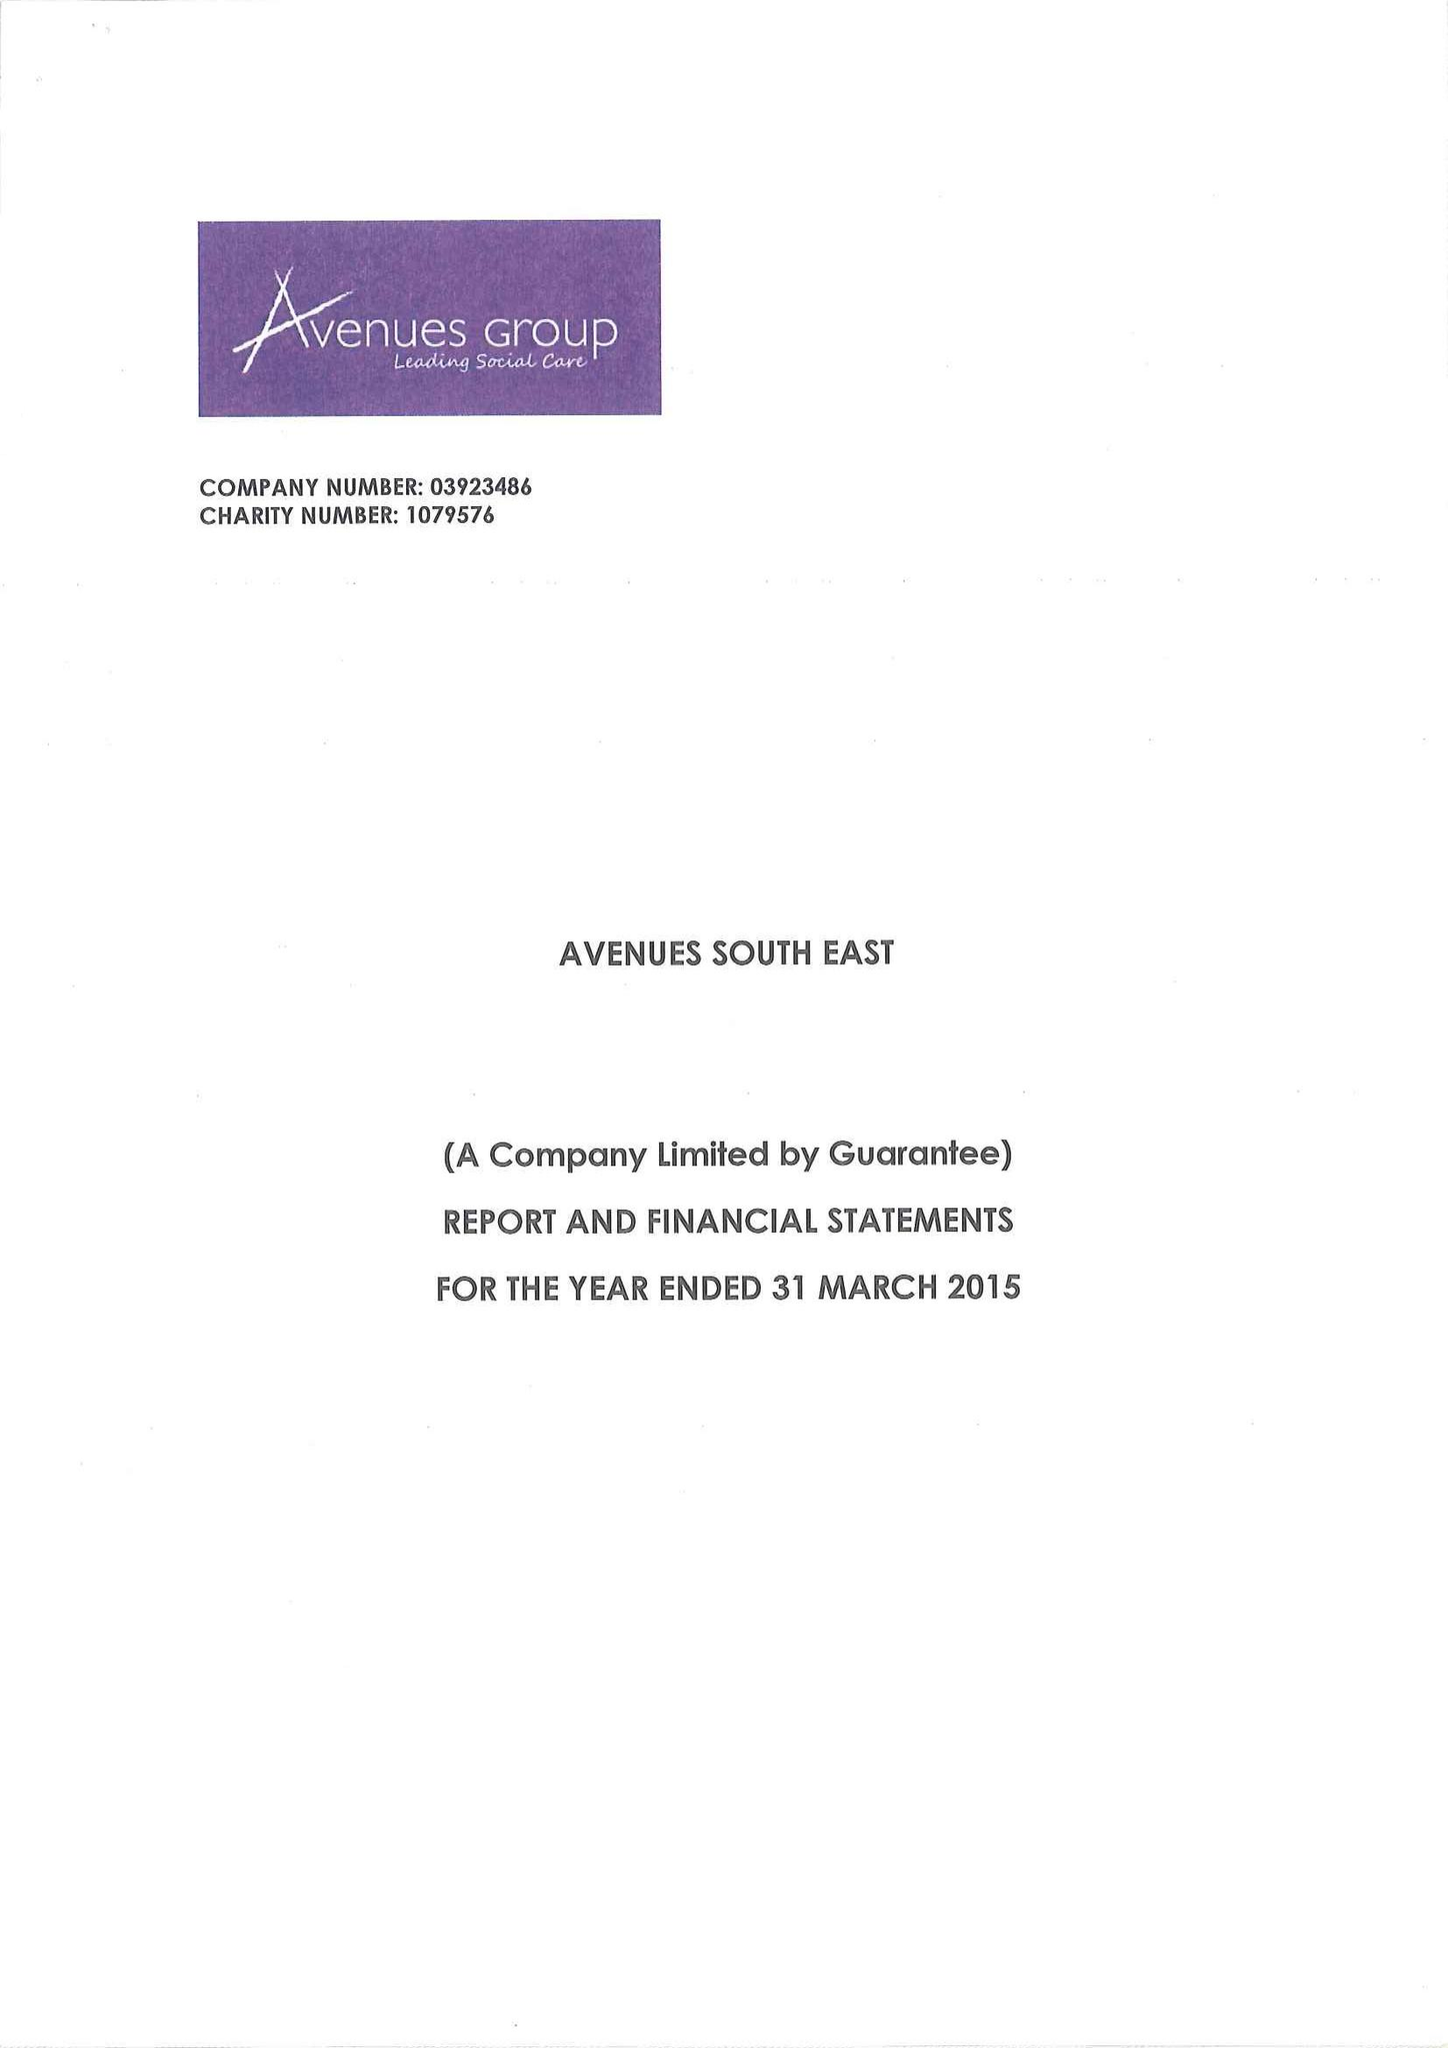What is the value for the charity_number?
Answer the question using a single word or phrase. 1079576 